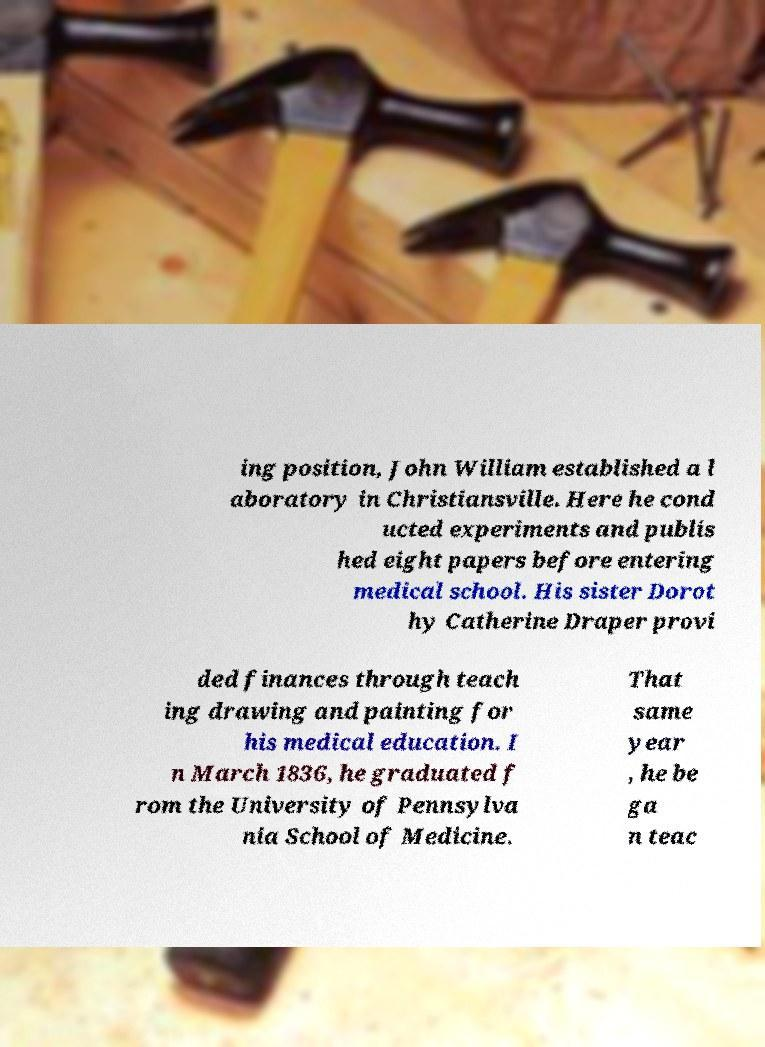There's text embedded in this image that I need extracted. Can you transcribe it verbatim? ing position, John William established a l aboratory in Christiansville. Here he cond ucted experiments and publis hed eight papers before entering medical school. His sister Dorot hy Catherine Draper provi ded finances through teach ing drawing and painting for his medical education. I n March 1836, he graduated f rom the University of Pennsylva nia School of Medicine. That same year , he be ga n teac 